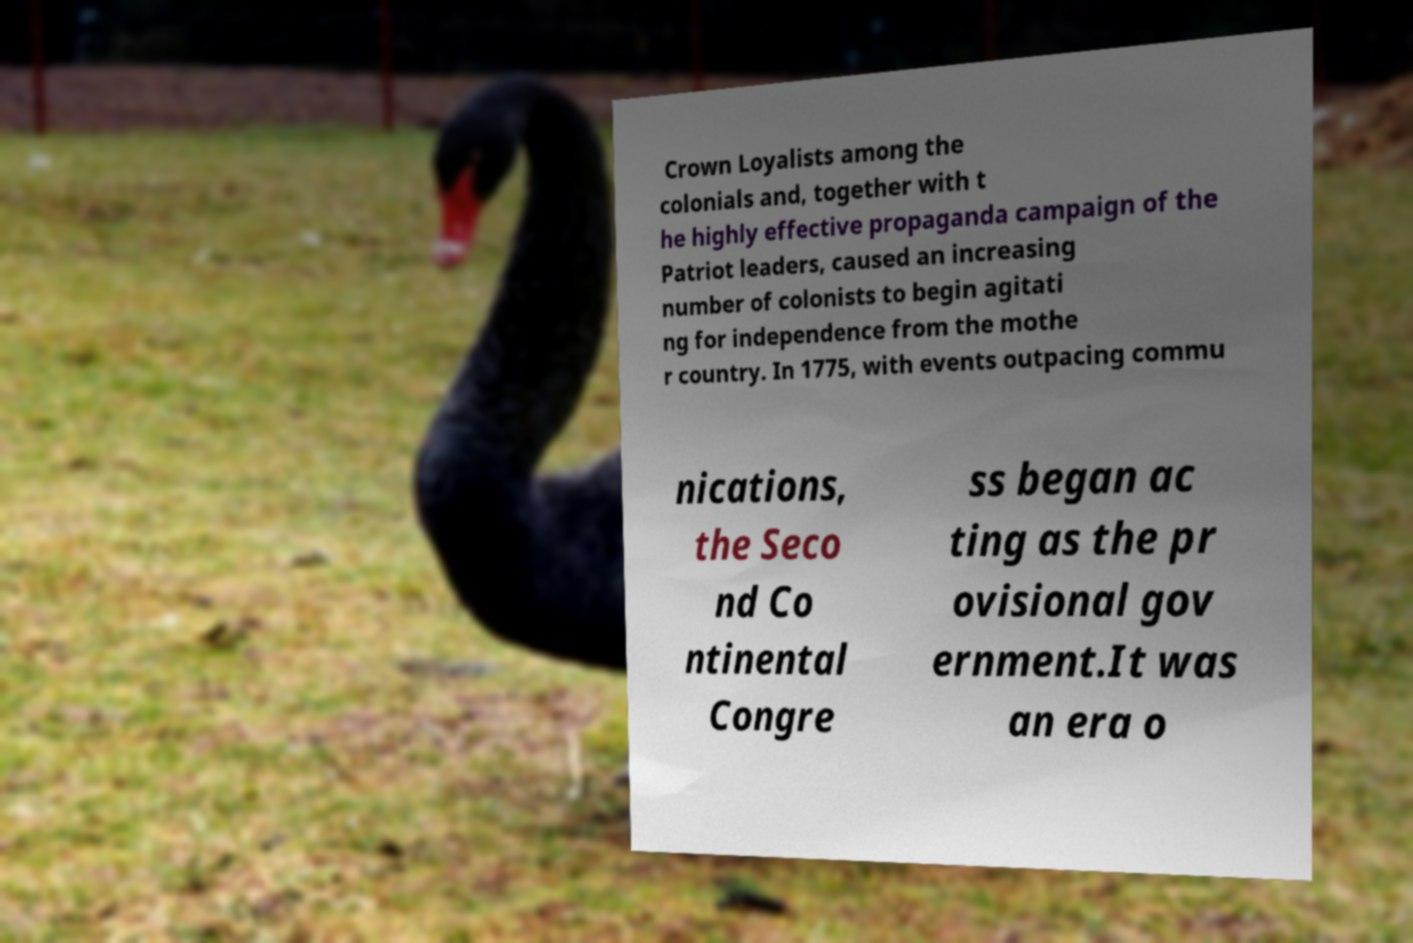For documentation purposes, I need the text within this image transcribed. Could you provide that? Crown Loyalists among the colonials and, together with t he highly effective propaganda campaign of the Patriot leaders, caused an increasing number of colonists to begin agitati ng for independence from the mothe r country. In 1775, with events outpacing commu nications, the Seco nd Co ntinental Congre ss began ac ting as the pr ovisional gov ernment.It was an era o 